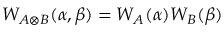<formula> <loc_0><loc_0><loc_500><loc_500>W _ { A \otimes B } ( \alpha , \beta ) = W _ { A } ( \alpha ) W _ { B } ( \beta )</formula> 